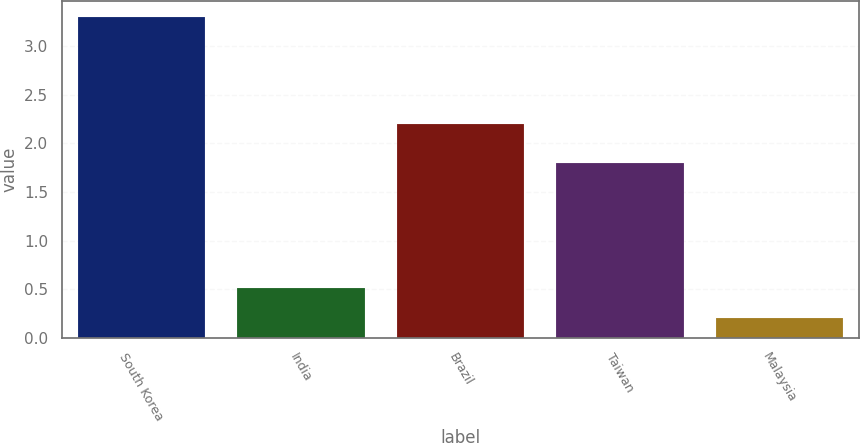Convert chart to OTSL. <chart><loc_0><loc_0><loc_500><loc_500><bar_chart><fcel>South Korea<fcel>India<fcel>Brazil<fcel>Taiwan<fcel>Malaysia<nl><fcel>3.3<fcel>0.51<fcel>2.2<fcel>1.8<fcel>0.2<nl></chart> 